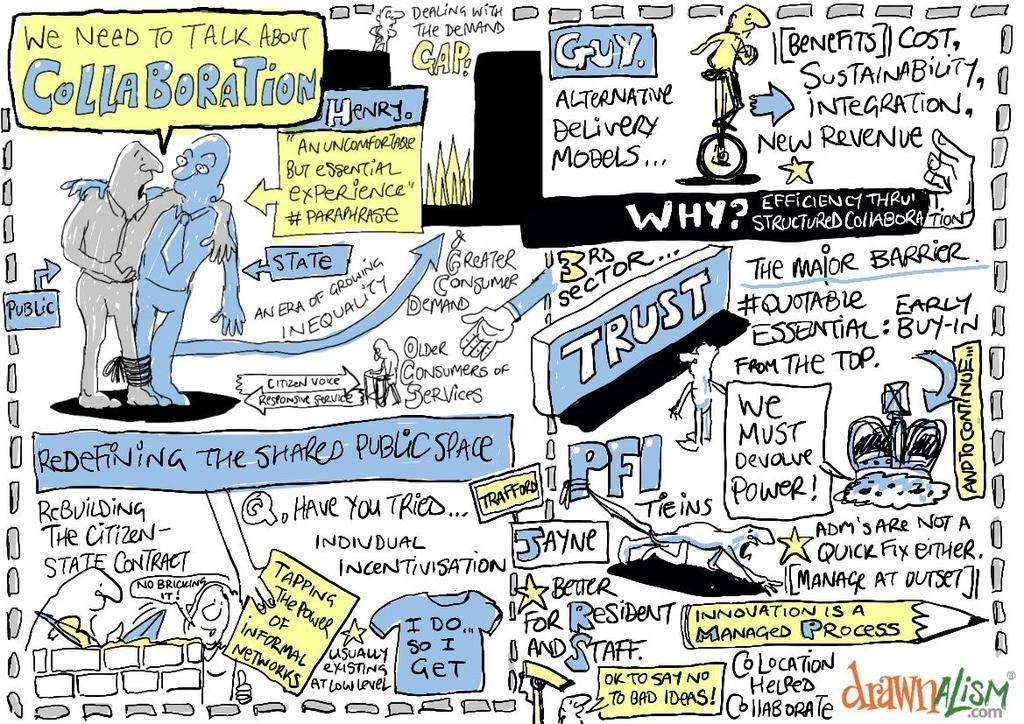What can be found in the image that contains written information? There is text in the image. What type of drawing is present in the image? There is a sketch of persons in the image. What type of lock is used to secure the brush in the image? There is no lock or brush present in the image; it only contains text and a sketch of persons. 